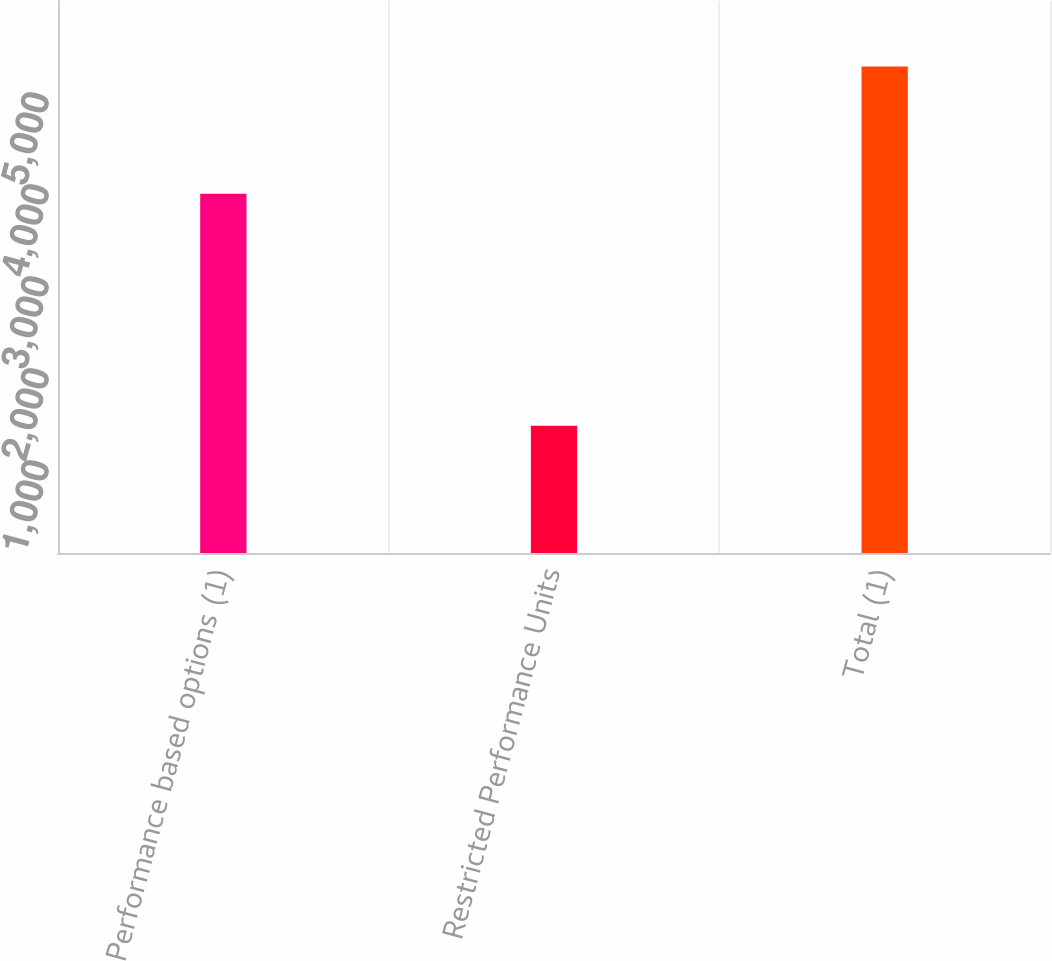Convert chart to OTSL. <chart><loc_0><loc_0><loc_500><loc_500><bar_chart><fcel>Performance based options (1)<fcel>Restricted Performance Units<fcel>Total (1)<nl><fcel>3905<fcel>1382<fcel>5287<nl></chart> 